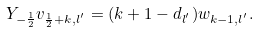Convert formula to latex. <formula><loc_0><loc_0><loc_500><loc_500>Y _ { - \frac { 1 } { 2 } } v _ { \frac { 1 } { 2 } + k , l ^ { ^ { \prime } } } = ( k + 1 - d _ { l ^ { ^ { \prime } } } ) w _ { k - 1 , l ^ { ^ { \prime } } } .</formula> 